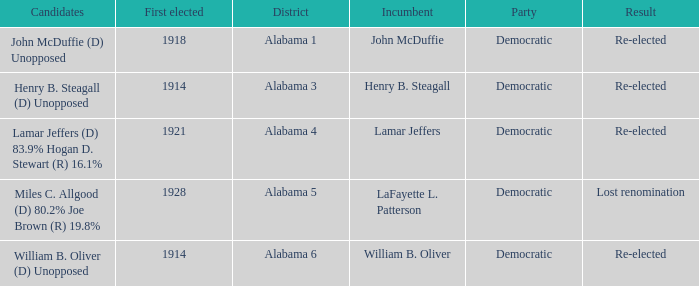How many in lost renomination results were elected first? 1928.0. 